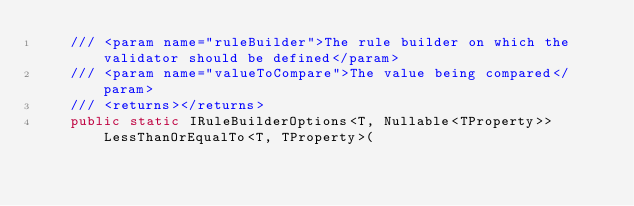Convert code to text. <code><loc_0><loc_0><loc_500><loc_500><_C#_>		/// <param name="ruleBuilder">The rule builder on which the validator should be defined</param>
		/// <param name="valueToCompare">The value being compared</param>
		/// <returns></returns>
		public static IRuleBuilderOptions<T, Nullable<TProperty>> LessThanOrEqualTo<T, TProperty>(</code> 